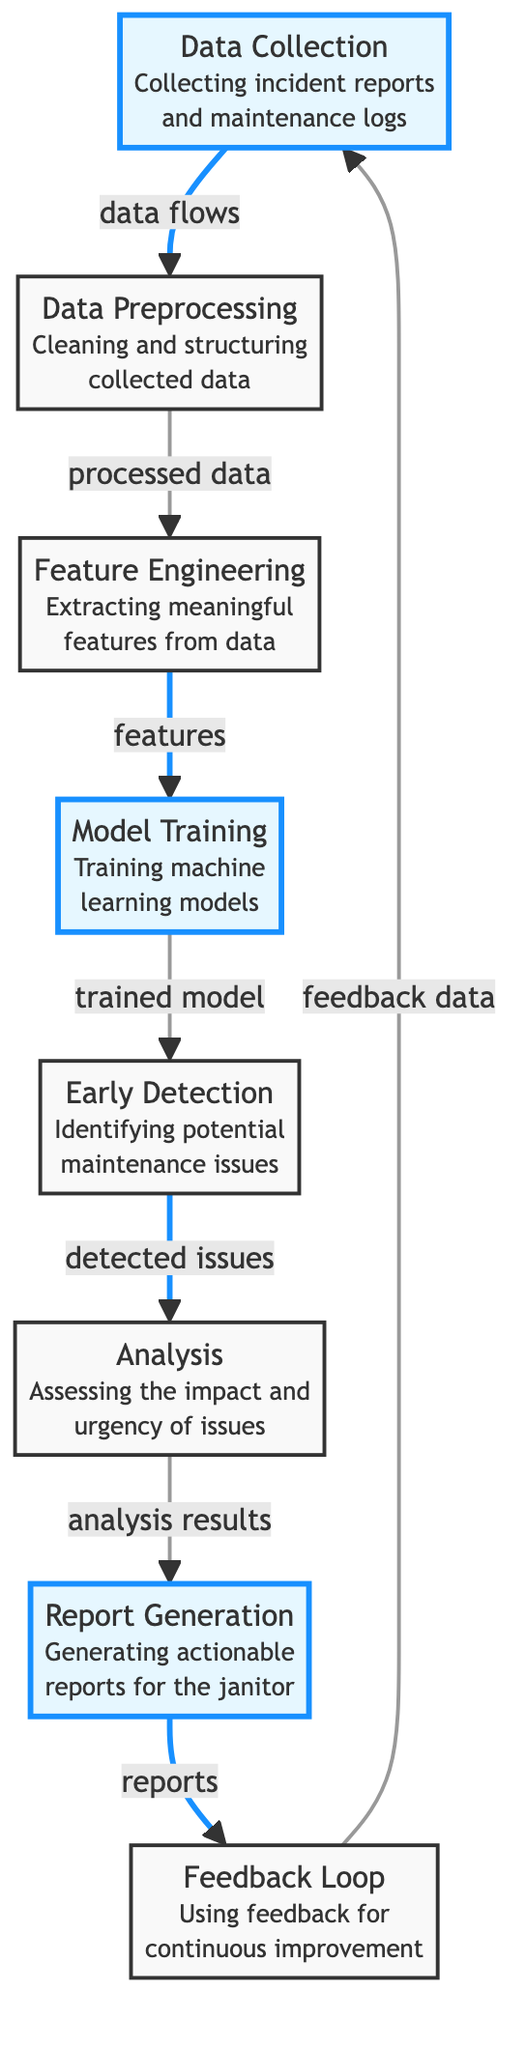What is the first step in the diagram? The first step in the diagram is "Data Collection." It is the initial process where incident reports and maintenance logs are gathered before any further processing.
Answer: Data Collection How many nodes are highlighted in the diagram? There are four highlighted nodes in the diagram, which are "Data Collection," "Model Training," "Report Generation," and "Early Detection." These nodes represent critical stages in the machine learning process.
Answer: Four What flows from "Data Preprocessing" to "Feature Engineering"? The flow from "Data Preprocessing" to "Feature Engineering" consists of processed data. This indicates that once the data is cleaned and structured, it is then prepared for feature extraction.
Answer: Processed Data Which node follows "Early Detection"? The node that follows "Early Detection" is "Analysis." This indicates that after potential maintenance issues are identified, they undergo an assessment to determine their impact and urgency.
Answer: Analysis What is the purpose of the "Feedback Loop" in the diagram? The purpose of the "Feedback Loop" is to use feedback data for continuous improvement within the incident reporting system. This ensures that the system learns and evolves over time based on the outcomes of previous reports and analyses.
Answer: Continuous Improvement How many stages are there between "Data Collection" and "Report Generation"? There are four stages between "Data Collection" and "Report Generation," which include "Data Preprocessing," "Feature Engineering," "Model Training," and "Early Detection." This sequence outlines the entire process from data gathering to actionable reporting.
Answer: Four What is generated after "Analysis"? After "Analysis," the output is "Report Generation." This means the results of the analysis are compiled into actionable reports specifically designed for the janitor to address maintenance issues.
Answer: Report Generation What type of data is used in the "Feedback Loop"? The "Feedback Loop" uses feedback data, which is essential for refining and enhancing the overall system's performance based on past incident reports and maintenance experiences.
Answer: Feedback Data 